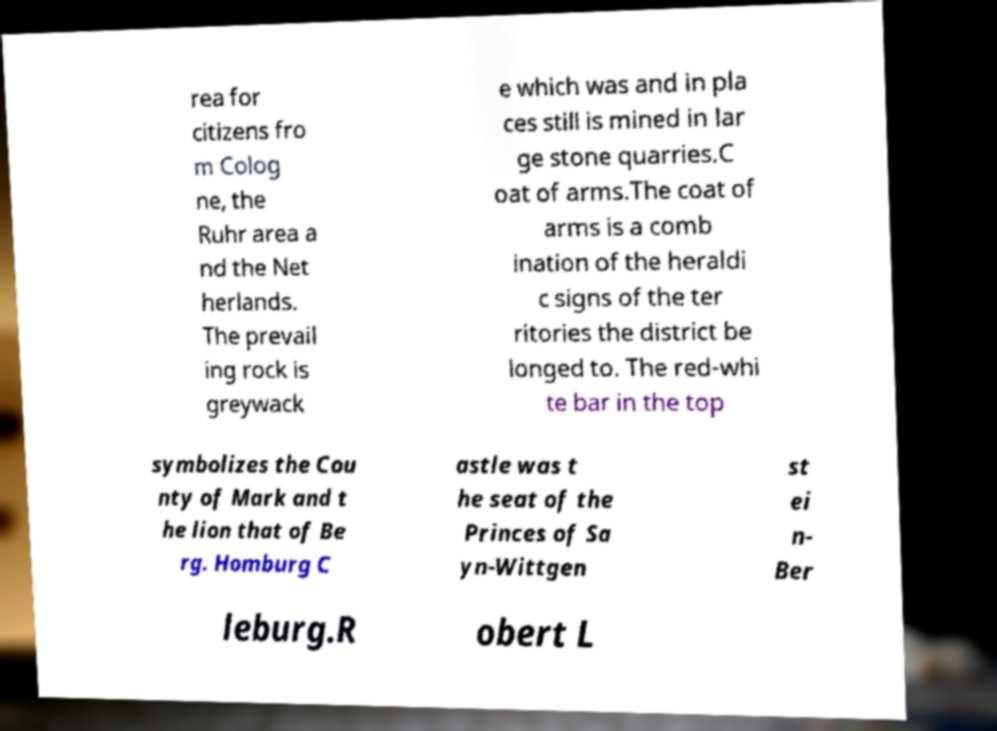Could you extract and type out the text from this image? rea for citizens fro m Colog ne, the Ruhr area a nd the Net herlands. The prevail ing rock is greywack e which was and in pla ces still is mined in lar ge stone quarries.C oat of arms.The coat of arms is a comb ination of the heraldi c signs of the ter ritories the district be longed to. The red-whi te bar in the top symbolizes the Cou nty of Mark and t he lion that of Be rg. Homburg C astle was t he seat of the Princes of Sa yn-Wittgen st ei n- Ber leburg.R obert L 